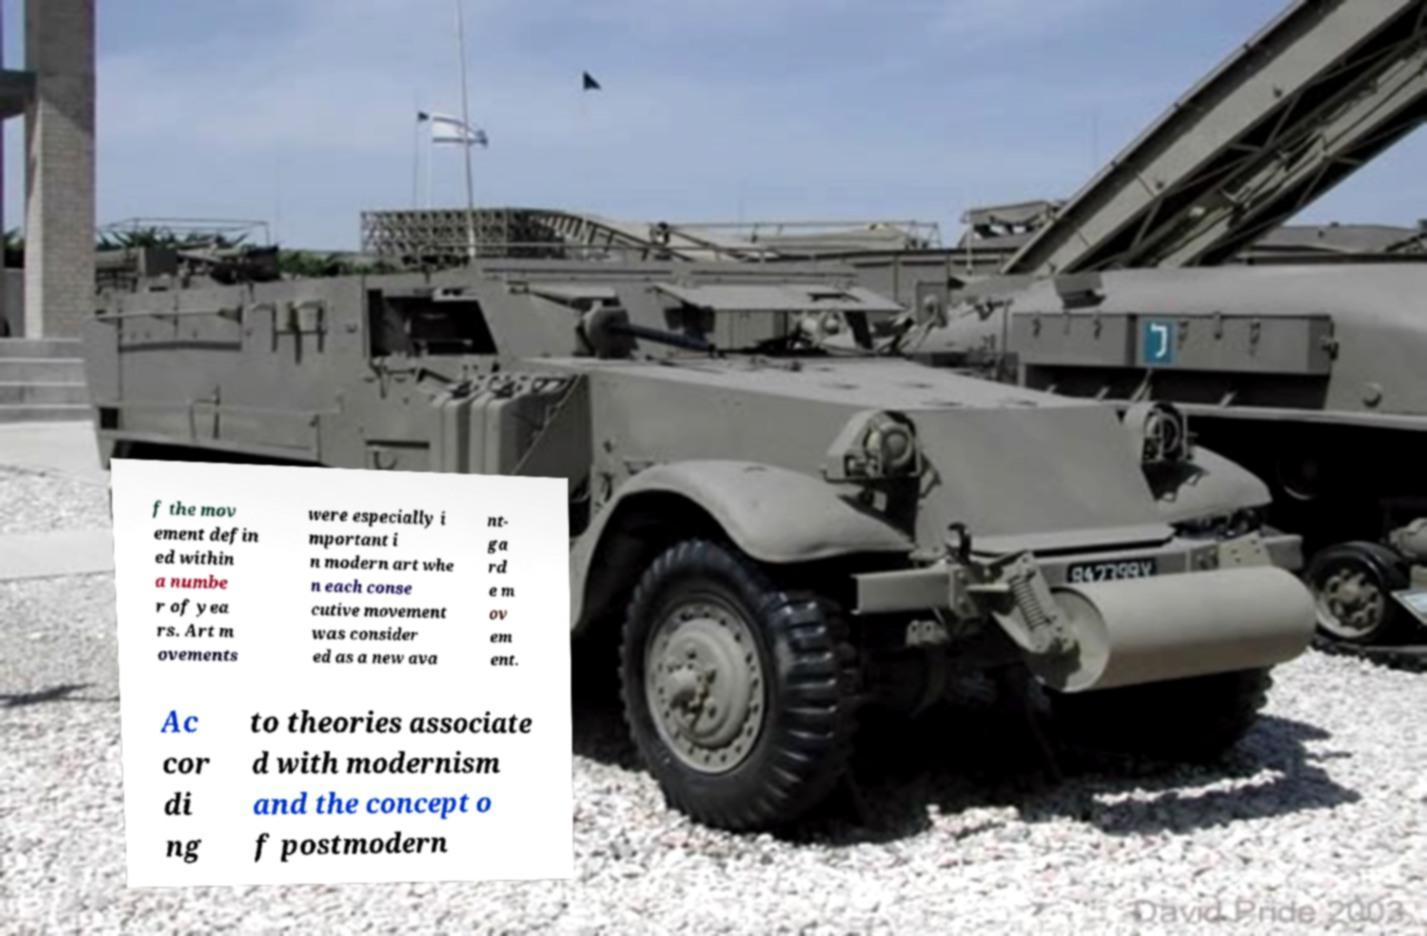What messages or text are displayed in this image? I need them in a readable, typed format. f the mov ement defin ed within a numbe r of yea rs. Art m ovements were especially i mportant i n modern art whe n each conse cutive movement was consider ed as a new ava nt- ga rd e m ov em ent. Ac cor di ng to theories associate d with modernism and the concept o f postmodern 